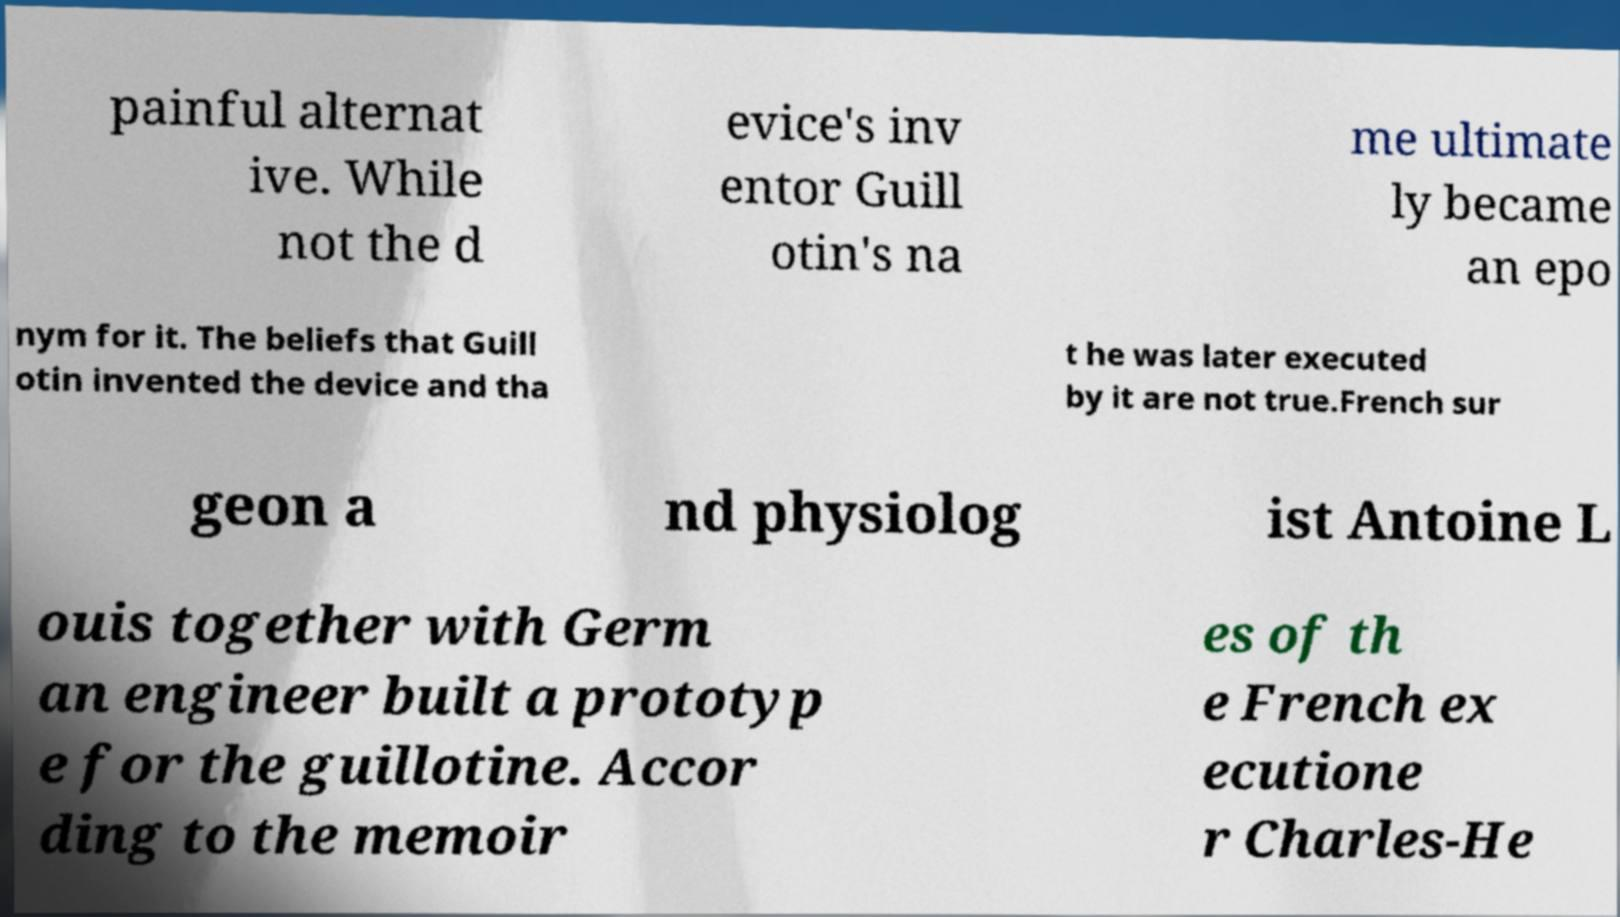Please read and relay the text visible in this image. What does it say? painful alternat ive. While not the d evice's inv entor Guill otin's na me ultimate ly became an epo nym for it. The beliefs that Guill otin invented the device and tha t he was later executed by it are not true.French sur geon a nd physiolog ist Antoine L ouis together with Germ an engineer built a prototyp e for the guillotine. Accor ding to the memoir es of th e French ex ecutione r Charles-He 